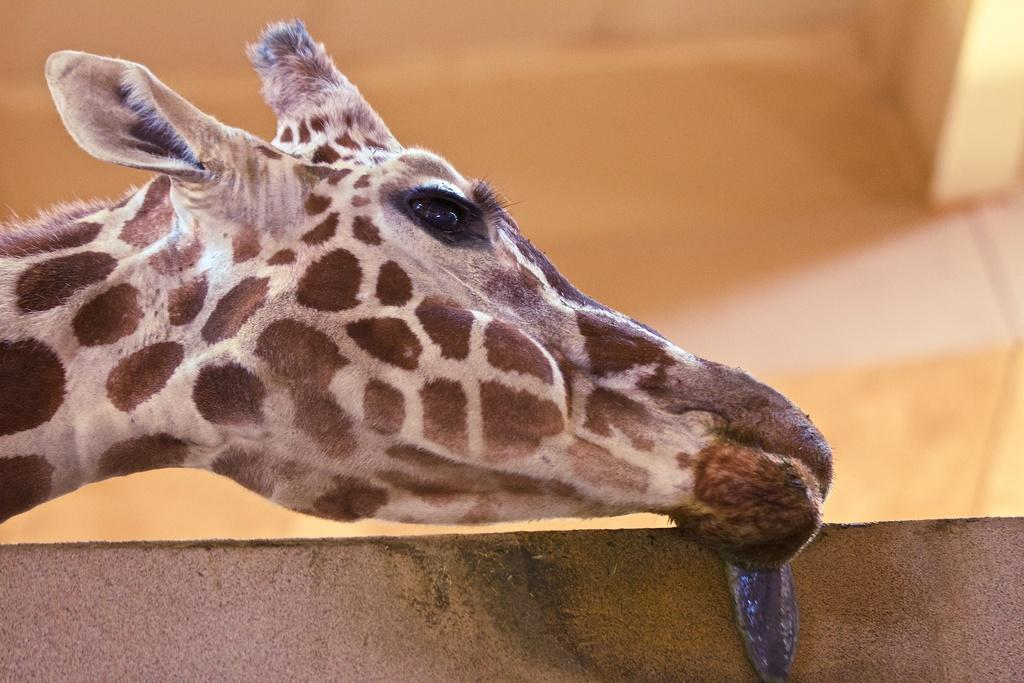What animal is the main subject of the image? There is a giraffe in the image. Can you describe the color of the giraffe? The giraffe has a cream and brown color. What color is the background of the image? The background of the image is in brown color. What type of cracker is the girl holding in the image? There is no girl or cracker present in the image; it features a giraffe with a cream and brown color against a brown background. 